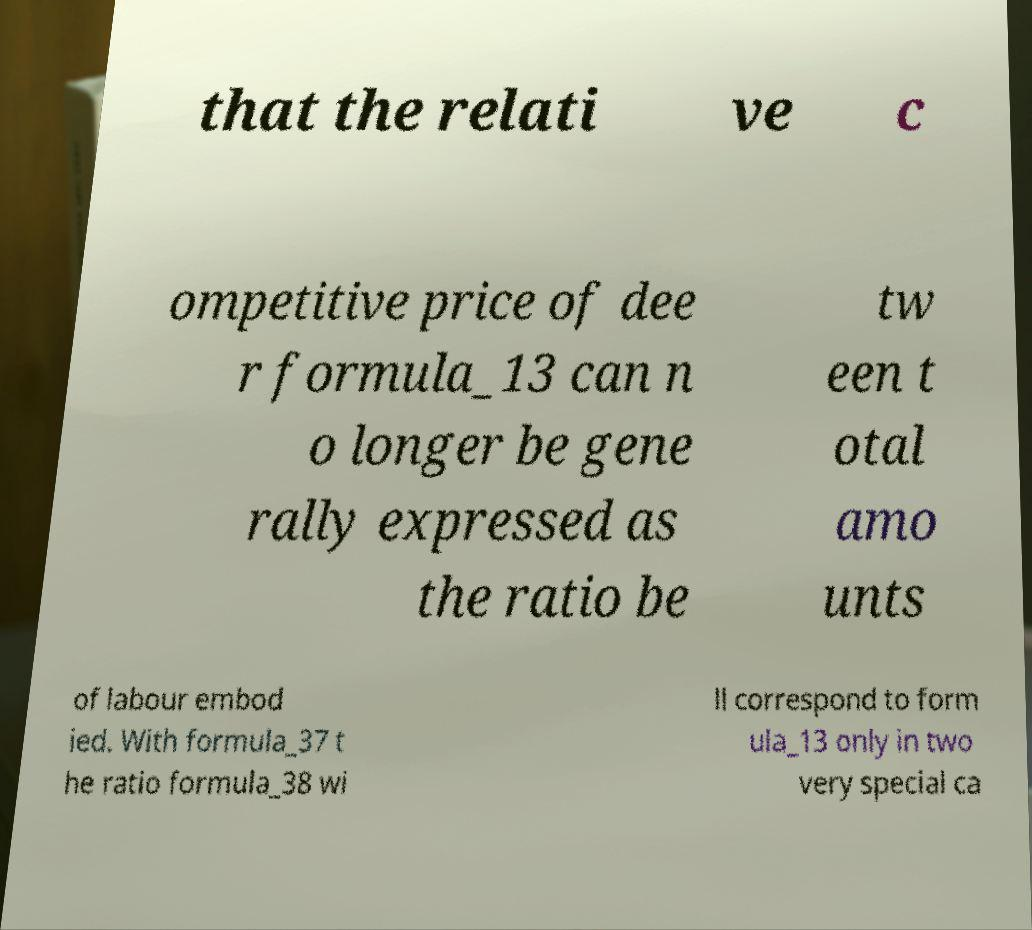For documentation purposes, I need the text within this image transcribed. Could you provide that? that the relati ve c ompetitive price of dee r formula_13 can n o longer be gene rally expressed as the ratio be tw een t otal amo unts of labour embod ied. With formula_37 t he ratio formula_38 wi ll correspond to form ula_13 only in two very special ca 